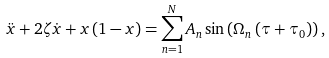Convert formula to latex. <formula><loc_0><loc_0><loc_500><loc_500>\ddot { x } + 2 \zeta \dot { x } + x \left ( 1 - x \right ) = \sum _ { n = 1 } ^ { N } A _ { n } \sin \left ( \Omega _ { n } \left ( \tau + \tau _ { 0 } \right ) \right ) ,</formula> 